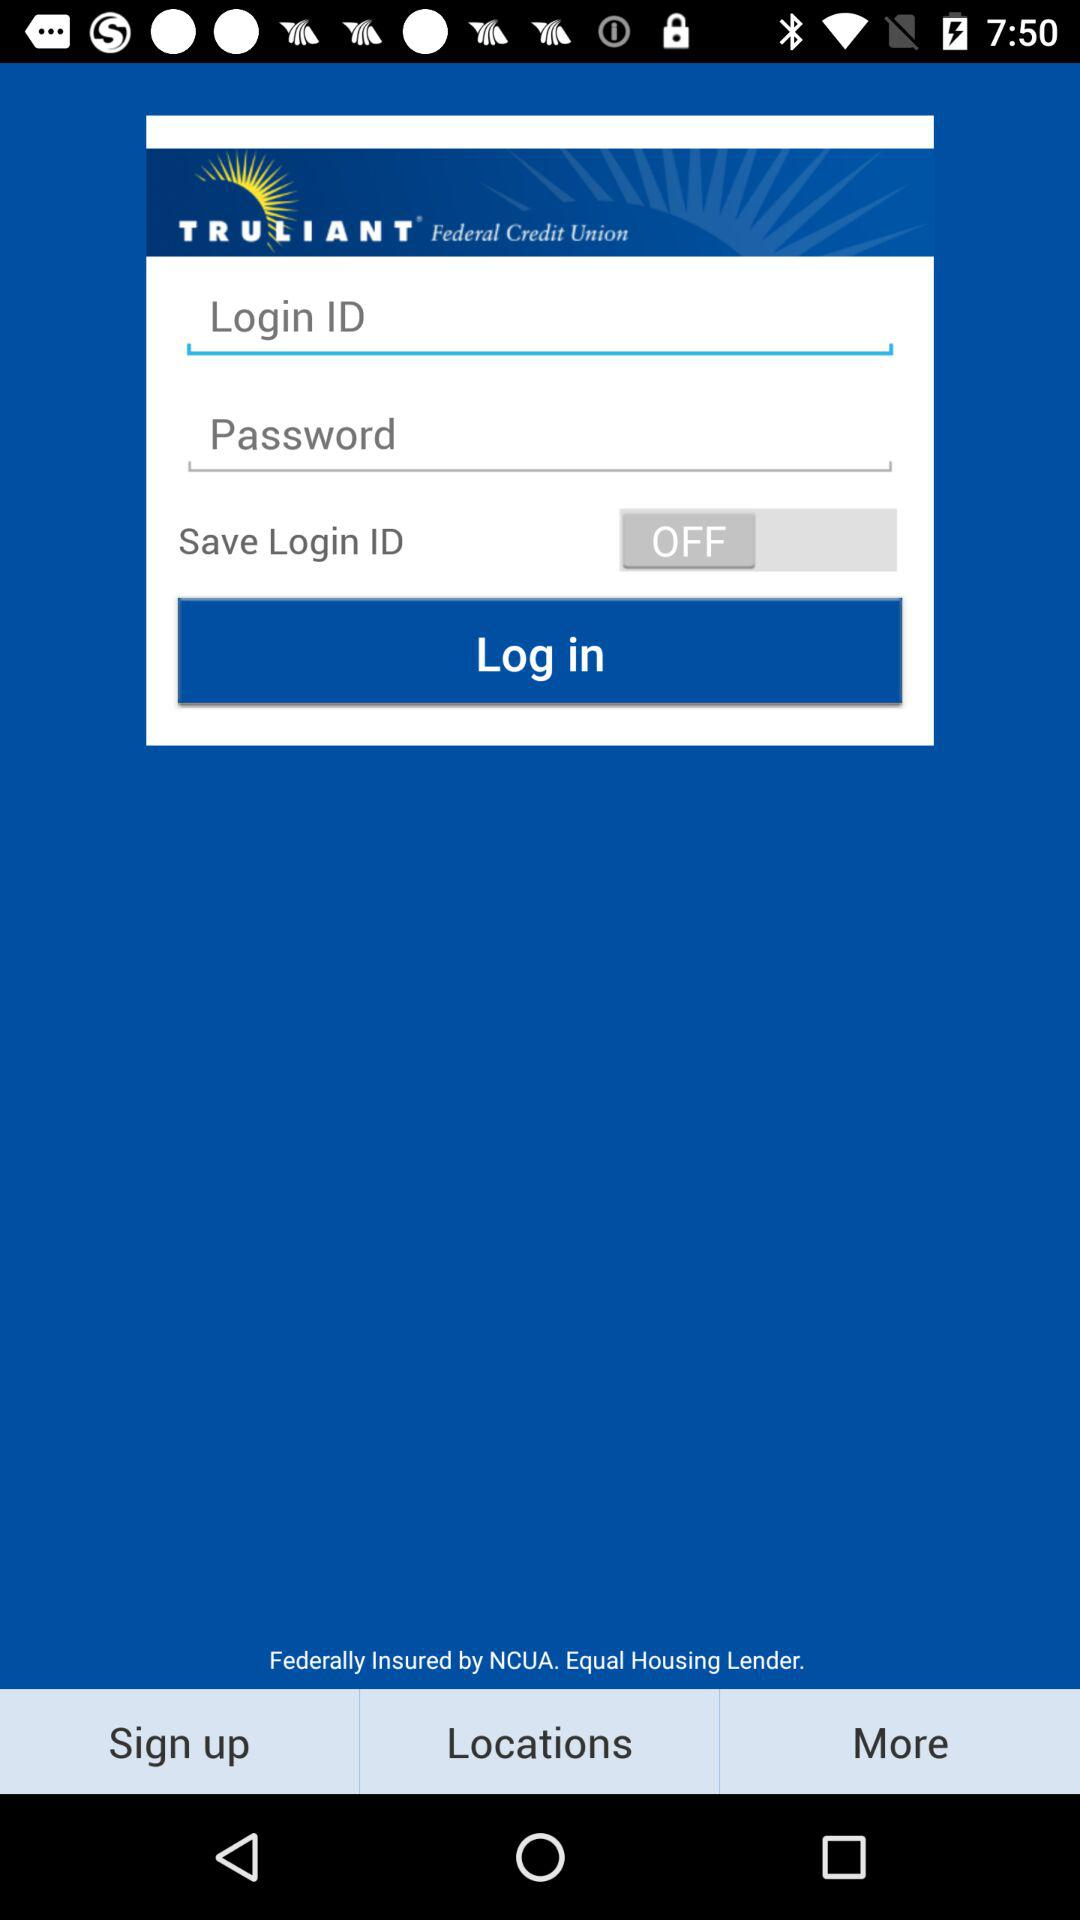How many text fields are there?
Answer the question using a single word or phrase. 2 